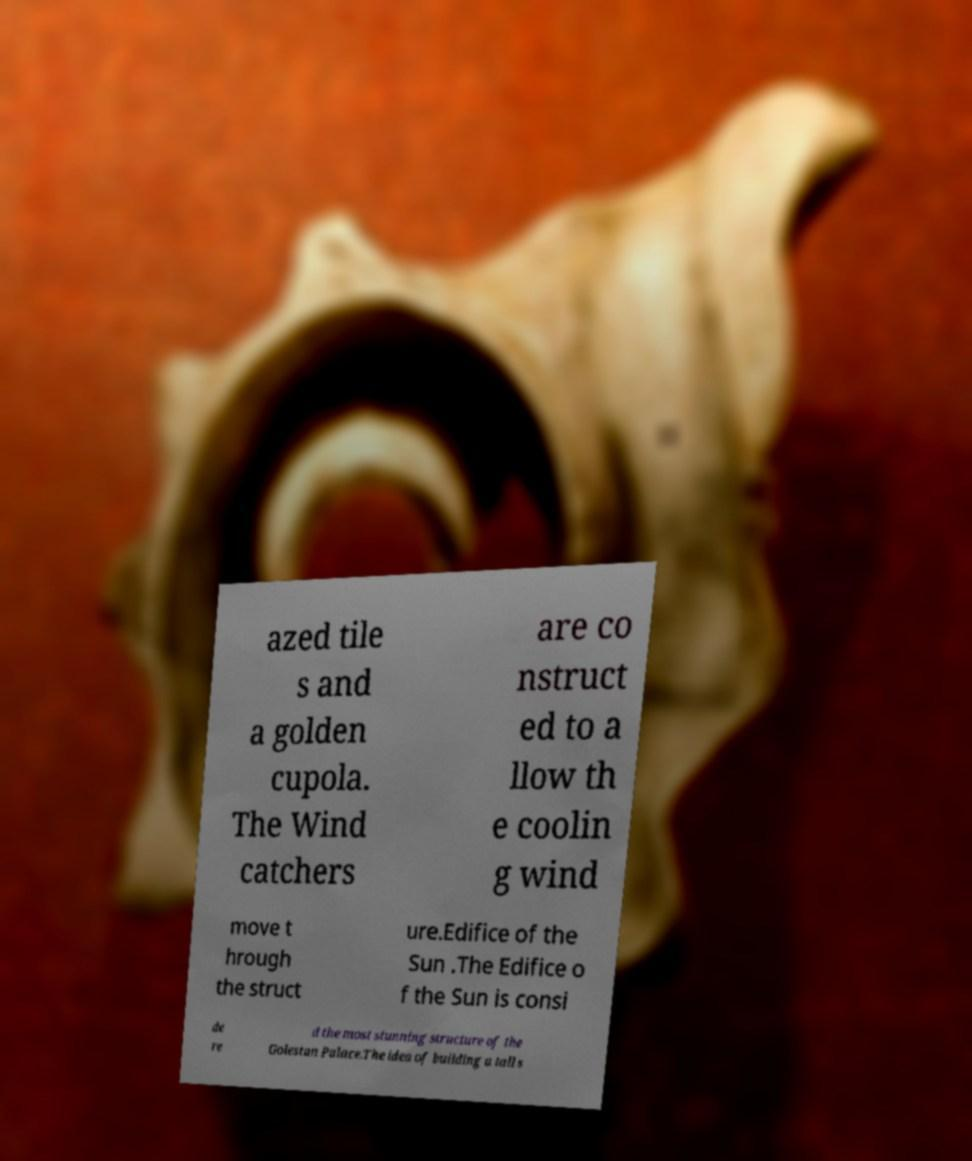Could you assist in decoding the text presented in this image and type it out clearly? azed tile s and a golden cupola. The Wind catchers are co nstruct ed to a llow th e coolin g wind move t hrough the struct ure.Edifice of the Sun .The Edifice o f the Sun is consi de re d the most stunning structure of the Golestan Palace.The idea of building a tall s 